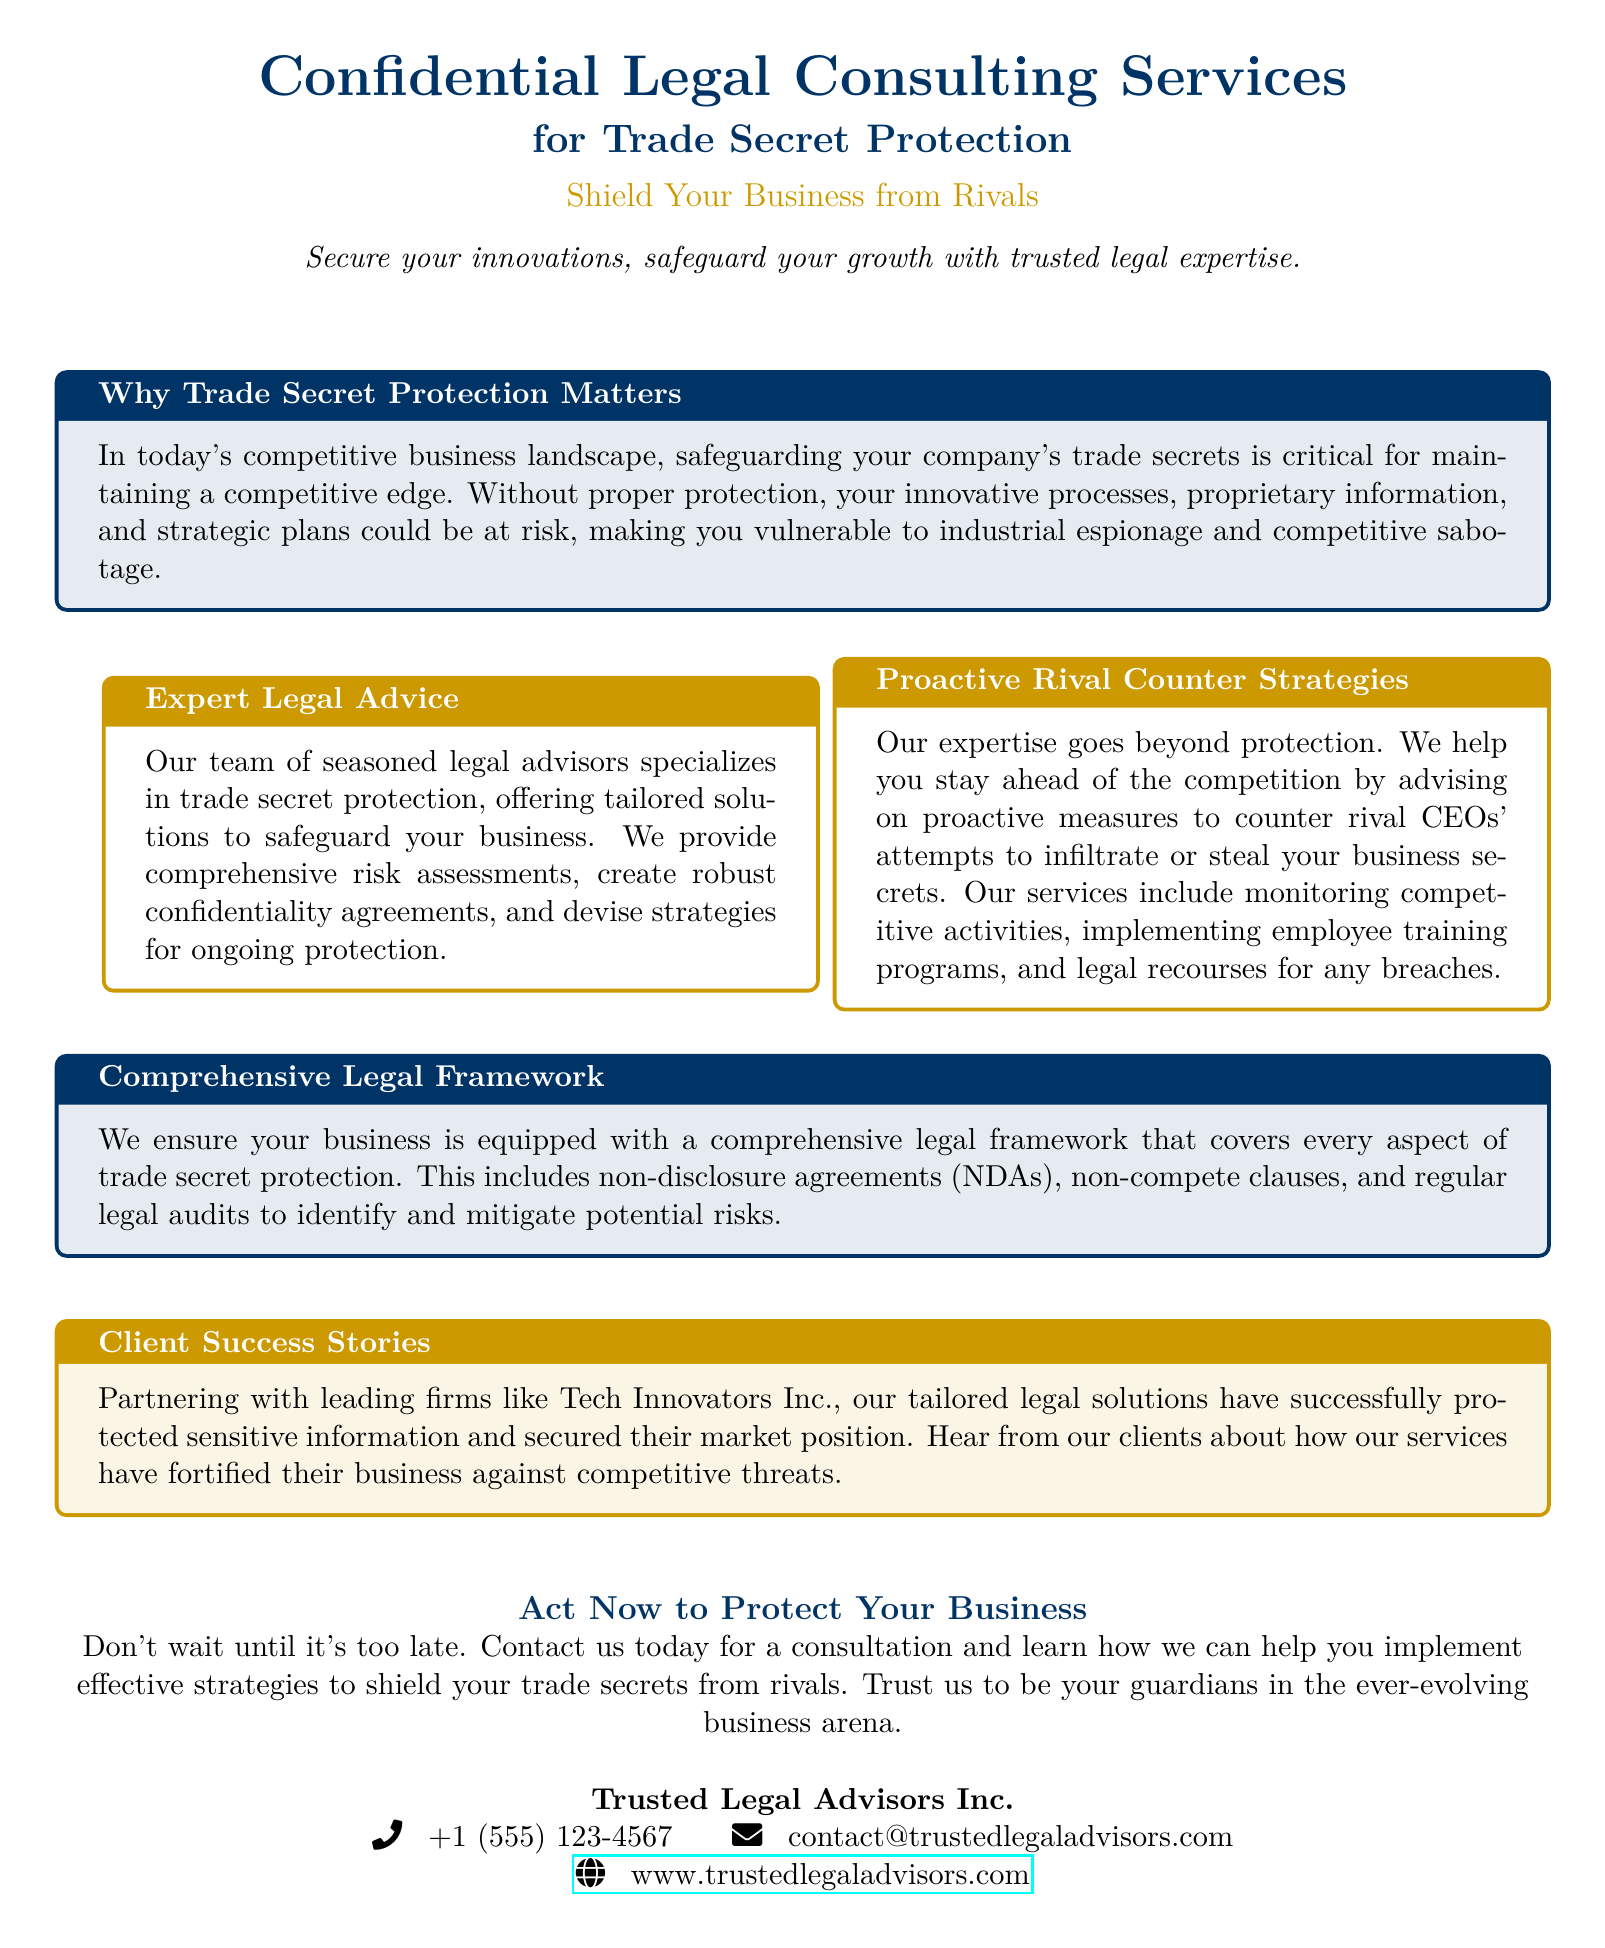What is the service offered? The advertisement explicitly states that the service offered is "Confidential Legal Consulting Services".
Answer: Confidential Legal Consulting Services What is the target focus of these services? The advertisement specifies that the focus is on "Trade Secret Protection".
Answer: Trade Secret Protection What is emphasized as a critical need for businesses today? The advertisement mentions that "safeguarding your company's trade secrets is critical".
Answer: Safeguarding trade secrets What types of legal documents are mentioned for trade secret protection? The document refers to "non-disclosure agreements (NDAs)" and "non-compete clauses".
Answer: Non-disclosure agreements and non-compete clauses Which company is highlighted as a client success story? The advertisement specifically mentions "Tech Innovators Inc."
Answer: Tech Innovators Inc What contact method is provided for inquiries? The advertisement includes a phone number for contact.
Answer: +1 (555) 123-4567 What is the call to action at the end of the document? The advertisement urges readers to "Contact us today for a consultation".
Answer: Contact us today What color is used for the title of the advertisement? The title is presented in the color defined as "maincolor".
Answer: maincolor What kind of strategies does the service provide against rival CEOs? The advertisement states that it provides "proactive measures to counter rival CEOs' attempts".
Answer: Proactive measures 